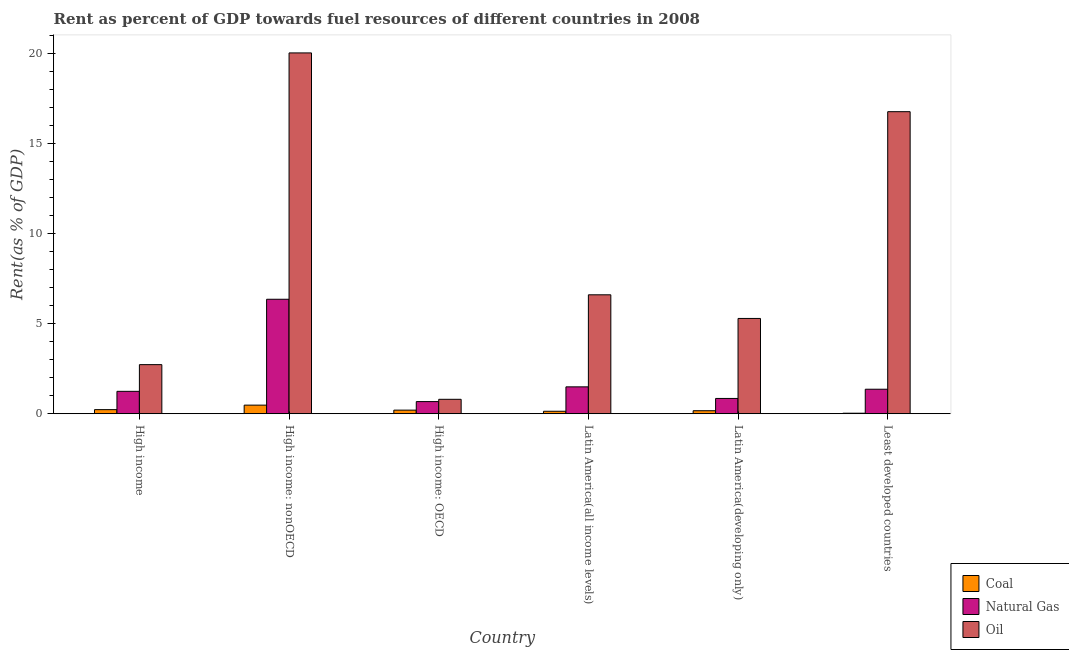How many different coloured bars are there?
Provide a short and direct response. 3. Are the number of bars per tick equal to the number of legend labels?
Your response must be concise. Yes. Are the number of bars on each tick of the X-axis equal?
Provide a succinct answer. Yes. How many bars are there on the 3rd tick from the left?
Make the answer very short. 3. What is the label of the 3rd group of bars from the left?
Your answer should be very brief. High income: OECD. What is the rent towards oil in Latin America(developing only)?
Keep it short and to the point. 5.29. Across all countries, what is the maximum rent towards natural gas?
Offer a terse response. 6.35. Across all countries, what is the minimum rent towards coal?
Make the answer very short. 0.03. In which country was the rent towards coal maximum?
Offer a terse response. High income: nonOECD. In which country was the rent towards natural gas minimum?
Your response must be concise. High income: OECD. What is the total rent towards coal in the graph?
Your answer should be compact. 1.24. What is the difference between the rent towards natural gas in High income: OECD and that in Latin America(developing only)?
Ensure brevity in your answer.  -0.17. What is the difference between the rent towards oil in Latin America(all income levels) and the rent towards natural gas in High income?
Provide a short and direct response. 5.36. What is the average rent towards natural gas per country?
Make the answer very short. 2. What is the difference between the rent towards coal and rent towards natural gas in High income?
Provide a succinct answer. -1.01. In how many countries, is the rent towards oil greater than 9 %?
Offer a very short reply. 2. What is the ratio of the rent towards natural gas in Latin America(developing only) to that in Least developed countries?
Your answer should be very brief. 0.62. What is the difference between the highest and the second highest rent towards oil?
Give a very brief answer. 3.26. What is the difference between the highest and the lowest rent towards coal?
Your answer should be compact. 0.45. What does the 1st bar from the left in Least developed countries represents?
Your answer should be compact. Coal. What does the 1st bar from the right in Least developed countries represents?
Your answer should be compact. Oil. How many bars are there?
Offer a terse response. 18. How many countries are there in the graph?
Make the answer very short. 6. What is the difference between two consecutive major ticks on the Y-axis?
Ensure brevity in your answer.  5. Are the values on the major ticks of Y-axis written in scientific E-notation?
Your response must be concise. No. Where does the legend appear in the graph?
Keep it short and to the point. Bottom right. How many legend labels are there?
Give a very brief answer. 3. How are the legend labels stacked?
Your answer should be compact. Vertical. What is the title of the graph?
Your response must be concise. Rent as percent of GDP towards fuel resources of different countries in 2008. Does "Food" appear as one of the legend labels in the graph?
Your answer should be very brief. No. What is the label or title of the Y-axis?
Provide a succinct answer. Rent(as % of GDP). What is the Rent(as % of GDP) of Coal in High income?
Provide a succinct answer. 0.23. What is the Rent(as % of GDP) of Natural Gas in High income?
Your answer should be compact. 1.24. What is the Rent(as % of GDP) of Oil in High income?
Keep it short and to the point. 2.73. What is the Rent(as % of GDP) of Coal in High income: nonOECD?
Give a very brief answer. 0.48. What is the Rent(as % of GDP) of Natural Gas in High income: nonOECD?
Give a very brief answer. 6.35. What is the Rent(as % of GDP) of Oil in High income: nonOECD?
Offer a terse response. 20.02. What is the Rent(as % of GDP) in Coal in High income: OECD?
Offer a very short reply. 0.2. What is the Rent(as % of GDP) in Natural Gas in High income: OECD?
Make the answer very short. 0.67. What is the Rent(as % of GDP) of Oil in High income: OECD?
Your answer should be compact. 0.8. What is the Rent(as % of GDP) of Coal in Latin America(all income levels)?
Keep it short and to the point. 0.14. What is the Rent(as % of GDP) of Natural Gas in Latin America(all income levels)?
Your response must be concise. 1.49. What is the Rent(as % of GDP) of Oil in Latin America(all income levels)?
Your response must be concise. 6.6. What is the Rent(as % of GDP) in Coal in Latin America(developing only)?
Ensure brevity in your answer.  0.17. What is the Rent(as % of GDP) of Natural Gas in Latin America(developing only)?
Offer a very short reply. 0.85. What is the Rent(as % of GDP) in Oil in Latin America(developing only)?
Your response must be concise. 5.29. What is the Rent(as % of GDP) of Coal in Least developed countries?
Provide a succinct answer. 0.03. What is the Rent(as % of GDP) of Natural Gas in Least developed countries?
Keep it short and to the point. 1.36. What is the Rent(as % of GDP) of Oil in Least developed countries?
Your response must be concise. 16.76. Across all countries, what is the maximum Rent(as % of GDP) of Coal?
Offer a terse response. 0.48. Across all countries, what is the maximum Rent(as % of GDP) in Natural Gas?
Make the answer very short. 6.35. Across all countries, what is the maximum Rent(as % of GDP) of Oil?
Offer a terse response. 20.02. Across all countries, what is the minimum Rent(as % of GDP) of Coal?
Make the answer very short. 0.03. Across all countries, what is the minimum Rent(as % of GDP) of Natural Gas?
Your response must be concise. 0.67. Across all countries, what is the minimum Rent(as % of GDP) in Oil?
Offer a terse response. 0.8. What is the total Rent(as % of GDP) in Coal in the graph?
Your response must be concise. 1.24. What is the total Rent(as % of GDP) of Natural Gas in the graph?
Make the answer very short. 11.97. What is the total Rent(as % of GDP) in Oil in the graph?
Ensure brevity in your answer.  52.19. What is the difference between the Rent(as % of GDP) in Coal in High income and that in High income: nonOECD?
Make the answer very short. -0.25. What is the difference between the Rent(as % of GDP) of Natural Gas in High income and that in High income: nonOECD?
Your response must be concise. -5.11. What is the difference between the Rent(as % of GDP) of Oil in High income and that in High income: nonOECD?
Offer a very short reply. -17.3. What is the difference between the Rent(as % of GDP) of Coal in High income and that in High income: OECD?
Provide a short and direct response. 0.03. What is the difference between the Rent(as % of GDP) of Natural Gas in High income and that in High income: OECD?
Provide a succinct answer. 0.57. What is the difference between the Rent(as % of GDP) of Oil in High income and that in High income: OECD?
Provide a succinct answer. 1.92. What is the difference between the Rent(as % of GDP) in Coal in High income and that in Latin America(all income levels)?
Offer a terse response. 0.09. What is the difference between the Rent(as % of GDP) of Natural Gas in High income and that in Latin America(all income levels)?
Your response must be concise. -0.25. What is the difference between the Rent(as % of GDP) in Oil in High income and that in Latin America(all income levels)?
Make the answer very short. -3.87. What is the difference between the Rent(as % of GDP) of Coal in High income and that in Latin America(developing only)?
Give a very brief answer. 0.06. What is the difference between the Rent(as % of GDP) in Natural Gas in High income and that in Latin America(developing only)?
Your answer should be compact. 0.39. What is the difference between the Rent(as % of GDP) in Oil in High income and that in Latin America(developing only)?
Your response must be concise. -2.56. What is the difference between the Rent(as % of GDP) of Coal in High income and that in Least developed countries?
Provide a succinct answer. 0.2. What is the difference between the Rent(as % of GDP) in Natural Gas in High income and that in Least developed countries?
Offer a terse response. -0.12. What is the difference between the Rent(as % of GDP) of Oil in High income and that in Least developed countries?
Your response must be concise. -14.03. What is the difference between the Rent(as % of GDP) in Coal in High income: nonOECD and that in High income: OECD?
Offer a terse response. 0.28. What is the difference between the Rent(as % of GDP) in Natural Gas in High income: nonOECD and that in High income: OECD?
Give a very brief answer. 5.68. What is the difference between the Rent(as % of GDP) of Oil in High income: nonOECD and that in High income: OECD?
Your response must be concise. 19.22. What is the difference between the Rent(as % of GDP) of Coal in High income: nonOECD and that in Latin America(all income levels)?
Provide a succinct answer. 0.34. What is the difference between the Rent(as % of GDP) of Natural Gas in High income: nonOECD and that in Latin America(all income levels)?
Ensure brevity in your answer.  4.86. What is the difference between the Rent(as % of GDP) of Oil in High income: nonOECD and that in Latin America(all income levels)?
Make the answer very short. 13.42. What is the difference between the Rent(as % of GDP) of Coal in High income: nonOECD and that in Latin America(developing only)?
Your answer should be compact. 0.31. What is the difference between the Rent(as % of GDP) of Natural Gas in High income: nonOECD and that in Latin America(developing only)?
Give a very brief answer. 5.5. What is the difference between the Rent(as % of GDP) in Oil in High income: nonOECD and that in Latin America(developing only)?
Make the answer very short. 14.73. What is the difference between the Rent(as % of GDP) of Coal in High income: nonOECD and that in Least developed countries?
Provide a succinct answer. 0.45. What is the difference between the Rent(as % of GDP) in Natural Gas in High income: nonOECD and that in Least developed countries?
Offer a very short reply. 4.99. What is the difference between the Rent(as % of GDP) in Oil in High income: nonOECD and that in Least developed countries?
Make the answer very short. 3.26. What is the difference between the Rent(as % of GDP) of Coal in High income: OECD and that in Latin America(all income levels)?
Your answer should be very brief. 0.06. What is the difference between the Rent(as % of GDP) in Natural Gas in High income: OECD and that in Latin America(all income levels)?
Offer a very short reply. -0.82. What is the difference between the Rent(as % of GDP) in Oil in High income: OECD and that in Latin America(all income levels)?
Give a very brief answer. -5.8. What is the difference between the Rent(as % of GDP) of Coal in High income: OECD and that in Latin America(developing only)?
Keep it short and to the point. 0.03. What is the difference between the Rent(as % of GDP) of Natural Gas in High income: OECD and that in Latin America(developing only)?
Your answer should be compact. -0.17. What is the difference between the Rent(as % of GDP) in Oil in High income: OECD and that in Latin America(developing only)?
Your answer should be compact. -4.49. What is the difference between the Rent(as % of GDP) in Coal in High income: OECD and that in Least developed countries?
Provide a short and direct response. 0.17. What is the difference between the Rent(as % of GDP) in Natural Gas in High income: OECD and that in Least developed countries?
Provide a short and direct response. -0.69. What is the difference between the Rent(as % of GDP) in Oil in High income: OECD and that in Least developed countries?
Keep it short and to the point. -15.96. What is the difference between the Rent(as % of GDP) of Coal in Latin America(all income levels) and that in Latin America(developing only)?
Keep it short and to the point. -0.03. What is the difference between the Rent(as % of GDP) in Natural Gas in Latin America(all income levels) and that in Latin America(developing only)?
Keep it short and to the point. 0.64. What is the difference between the Rent(as % of GDP) of Oil in Latin America(all income levels) and that in Latin America(developing only)?
Provide a short and direct response. 1.31. What is the difference between the Rent(as % of GDP) of Coal in Latin America(all income levels) and that in Least developed countries?
Make the answer very short. 0.11. What is the difference between the Rent(as % of GDP) in Natural Gas in Latin America(all income levels) and that in Least developed countries?
Your answer should be compact. 0.13. What is the difference between the Rent(as % of GDP) in Oil in Latin America(all income levels) and that in Least developed countries?
Provide a succinct answer. -10.16. What is the difference between the Rent(as % of GDP) in Coal in Latin America(developing only) and that in Least developed countries?
Offer a very short reply. 0.14. What is the difference between the Rent(as % of GDP) in Natural Gas in Latin America(developing only) and that in Least developed countries?
Your answer should be very brief. -0.51. What is the difference between the Rent(as % of GDP) of Oil in Latin America(developing only) and that in Least developed countries?
Your response must be concise. -11.47. What is the difference between the Rent(as % of GDP) in Coal in High income and the Rent(as % of GDP) in Natural Gas in High income: nonOECD?
Offer a very short reply. -6.12. What is the difference between the Rent(as % of GDP) in Coal in High income and the Rent(as % of GDP) in Oil in High income: nonOECD?
Give a very brief answer. -19.79. What is the difference between the Rent(as % of GDP) of Natural Gas in High income and the Rent(as % of GDP) of Oil in High income: nonOECD?
Provide a short and direct response. -18.78. What is the difference between the Rent(as % of GDP) in Coal in High income and the Rent(as % of GDP) in Natural Gas in High income: OECD?
Your answer should be very brief. -0.45. What is the difference between the Rent(as % of GDP) of Coal in High income and the Rent(as % of GDP) of Oil in High income: OECD?
Provide a succinct answer. -0.57. What is the difference between the Rent(as % of GDP) of Natural Gas in High income and the Rent(as % of GDP) of Oil in High income: OECD?
Offer a terse response. 0.44. What is the difference between the Rent(as % of GDP) in Coal in High income and the Rent(as % of GDP) in Natural Gas in Latin America(all income levels)?
Provide a succinct answer. -1.26. What is the difference between the Rent(as % of GDP) of Coal in High income and the Rent(as % of GDP) of Oil in Latin America(all income levels)?
Provide a short and direct response. -6.37. What is the difference between the Rent(as % of GDP) of Natural Gas in High income and the Rent(as % of GDP) of Oil in Latin America(all income levels)?
Provide a succinct answer. -5.36. What is the difference between the Rent(as % of GDP) in Coal in High income and the Rent(as % of GDP) in Natural Gas in Latin America(developing only)?
Keep it short and to the point. -0.62. What is the difference between the Rent(as % of GDP) of Coal in High income and the Rent(as % of GDP) of Oil in Latin America(developing only)?
Keep it short and to the point. -5.06. What is the difference between the Rent(as % of GDP) in Natural Gas in High income and the Rent(as % of GDP) in Oil in Latin America(developing only)?
Keep it short and to the point. -4.04. What is the difference between the Rent(as % of GDP) in Coal in High income and the Rent(as % of GDP) in Natural Gas in Least developed countries?
Give a very brief answer. -1.13. What is the difference between the Rent(as % of GDP) in Coal in High income and the Rent(as % of GDP) in Oil in Least developed countries?
Provide a short and direct response. -16.53. What is the difference between the Rent(as % of GDP) of Natural Gas in High income and the Rent(as % of GDP) of Oil in Least developed countries?
Ensure brevity in your answer.  -15.52. What is the difference between the Rent(as % of GDP) in Coal in High income: nonOECD and the Rent(as % of GDP) in Natural Gas in High income: OECD?
Keep it short and to the point. -0.2. What is the difference between the Rent(as % of GDP) in Coal in High income: nonOECD and the Rent(as % of GDP) in Oil in High income: OECD?
Provide a short and direct response. -0.32. What is the difference between the Rent(as % of GDP) of Natural Gas in High income: nonOECD and the Rent(as % of GDP) of Oil in High income: OECD?
Provide a succinct answer. 5.55. What is the difference between the Rent(as % of GDP) of Coal in High income: nonOECD and the Rent(as % of GDP) of Natural Gas in Latin America(all income levels)?
Provide a succinct answer. -1.01. What is the difference between the Rent(as % of GDP) in Coal in High income: nonOECD and the Rent(as % of GDP) in Oil in Latin America(all income levels)?
Offer a terse response. -6.12. What is the difference between the Rent(as % of GDP) in Natural Gas in High income: nonOECD and the Rent(as % of GDP) in Oil in Latin America(all income levels)?
Your answer should be very brief. -0.25. What is the difference between the Rent(as % of GDP) of Coal in High income: nonOECD and the Rent(as % of GDP) of Natural Gas in Latin America(developing only)?
Ensure brevity in your answer.  -0.37. What is the difference between the Rent(as % of GDP) of Coal in High income: nonOECD and the Rent(as % of GDP) of Oil in Latin America(developing only)?
Ensure brevity in your answer.  -4.81. What is the difference between the Rent(as % of GDP) of Natural Gas in High income: nonOECD and the Rent(as % of GDP) of Oil in Latin America(developing only)?
Offer a terse response. 1.06. What is the difference between the Rent(as % of GDP) of Coal in High income: nonOECD and the Rent(as % of GDP) of Natural Gas in Least developed countries?
Your response must be concise. -0.88. What is the difference between the Rent(as % of GDP) of Coal in High income: nonOECD and the Rent(as % of GDP) of Oil in Least developed countries?
Your answer should be compact. -16.28. What is the difference between the Rent(as % of GDP) in Natural Gas in High income: nonOECD and the Rent(as % of GDP) in Oil in Least developed countries?
Provide a succinct answer. -10.41. What is the difference between the Rent(as % of GDP) in Coal in High income: OECD and the Rent(as % of GDP) in Natural Gas in Latin America(all income levels)?
Your response must be concise. -1.29. What is the difference between the Rent(as % of GDP) of Coal in High income: OECD and the Rent(as % of GDP) of Oil in Latin America(all income levels)?
Your answer should be very brief. -6.4. What is the difference between the Rent(as % of GDP) in Natural Gas in High income: OECD and the Rent(as % of GDP) in Oil in Latin America(all income levels)?
Your response must be concise. -5.92. What is the difference between the Rent(as % of GDP) in Coal in High income: OECD and the Rent(as % of GDP) in Natural Gas in Latin America(developing only)?
Provide a short and direct response. -0.65. What is the difference between the Rent(as % of GDP) of Coal in High income: OECD and the Rent(as % of GDP) of Oil in Latin America(developing only)?
Provide a succinct answer. -5.09. What is the difference between the Rent(as % of GDP) of Natural Gas in High income: OECD and the Rent(as % of GDP) of Oil in Latin America(developing only)?
Keep it short and to the point. -4.61. What is the difference between the Rent(as % of GDP) in Coal in High income: OECD and the Rent(as % of GDP) in Natural Gas in Least developed countries?
Make the answer very short. -1.16. What is the difference between the Rent(as % of GDP) of Coal in High income: OECD and the Rent(as % of GDP) of Oil in Least developed countries?
Make the answer very short. -16.56. What is the difference between the Rent(as % of GDP) of Natural Gas in High income: OECD and the Rent(as % of GDP) of Oil in Least developed countries?
Your answer should be very brief. -16.08. What is the difference between the Rent(as % of GDP) in Coal in Latin America(all income levels) and the Rent(as % of GDP) in Natural Gas in Latin America(developing only)?
Your answer should be compact. -0.71. What is the difference between the Rent(as % of GDP) of Coal in Latin America(all income levels) and the Rent(as % of GDP) of Oil in Latin America(developing only)?
Make the answer very short. -5.15. What is the difference between the Rent(as % of GDP) of Natural Gas in Latin America(all income levels) and the Rent(as % of GDP) of Oil in Latin America(developing only)?
Offer a terse response. -3.8. What is the difference between the Rent(as % of GDP) of Coal in Latin America(all income levels) and the Rent(as % of GDP) of Natural Gas in Least developed countries?
Make the answer very short. -1.22. What is the difference between the Rent(as % of GDP) in Coal in Latin America(all income levels) and the Rent(as % of GDP) in Oil in Least developed countries?
Offer a terse response. -16.62. What is the difference between the Rent(as % of GDP) of Natural Gas in Latin America(all income levels) and the Rent(as % of GDP) of Oil in Least developed countries?
Keep it short and to the point. -15.27. What is the difference between the Rent(as % of GDP) of Coal in Latin America(developing only) and the Rent(as % of GDP) of Natural Gas in Least developed countries?
Offer a terse response. -1.19. What is the difference between the Rent(as % of GDP) of Coal in Latin America(developing only) and the Rent(as % of GDP) of Oil in Least developed countries?
Your answer should be very brief. -16.59. What is the difference between the Rent(as % of GDP) of Natural Gas in Latin America(developing only) and the Rent(as % of GDP) of Oil in Least developed countries?
Your response must be concise. -15.91. What is the average Rent(as % of GDP) in Coal per country?
Keep it short and to the point. 0.21. What is the average Rent(as % of GDP) in Natural Gas per country?
Make the answer very short. 2. What is the average Rent(as % of GDP) of Oil per country?
Ensure brevity in your answer.  8.7. What is the difference between the Rent(as % of GDP) of Coal and Rent(as % of GDP) of Natural Gas in High income?
Provide a succinct answer. -1.01. What is the difference between the Rent(as % of GDP) in Coal and Rent(as % of GDP) in Oil in High income?
Your answer should be very brief. -2.5. What is the difference between the Rent(as % of GDP) of Natural Gas and Rent(as % of GDP) of Oil in High income?
Offer a terse response. -1.48. What is the difference between the Rent(as % of GDP) of Coal and Rent(as % of GDP) of Natural Gas in High income: nonOECD?
Provide a short and direct response. -5.87. What is the difference between the Rent(as % of GDP) of Coal and Rent(as % of GDP) of Oil in High income: nonOECD?
Offer a very short reply. -19.54. What is the difference between the Rent(as % of GDP) of Natural Gas and Rent(as % of GDP) of Oil in High income: nonOECD?
Provide a short and direct response. -13.67. What is the difference between the Rent(as % of GDP) in Coal and Rent(as % of GDP) in Natural Gas in High income: OECD?
Your answer should be very brief. -0.47. What is the difference between the Rent(as % of GDP) in Coal and Rent(as % of GDP) in Oil in High income: OECD?
Give a very brief answer. -0.6. What is the difference between the Rent(as % of GDP) in Natural Gas and Rent(as % of GDP) in Oil in High income: OECD?
Your answer should be very brief. -0.13. What is the difference between the Rent(as % of GDP) of Coal and Rent(as % of GDP) of Natural Gas in Latin America(all income levels)?
Offer a very short reply. -1.35. What is the difference between the Rent(as % of GDP) in Coal and Rent(as % of GDP) in Oil in Latin America(all income levels)?
Your answer should be very brief. -6.46. What is the difference between the Rent(as % of GDP) of Natural Gas and Rent(as % of GDP) of Oil in Latin America(all income levels)?
Provide a succinct answer. -5.11. What is the difference between the Rent(as % of GDP) in Coal and Rent(as % of GDP) in Natural Gas in Latin America(developing only)?
Provide a short and direct response. -0.68. What is the difference between the Rent(as % of GDP) of Coal and Rent(as % of GDP) of Oil in Latin America(developing only)?
Offer a very short reply. -5.12. What is the difference between the Rent(as % of GDP) in Natural Gas and Rent(as % of GDP) in Oil in Latin America(developing only)?
Your answer should be very brief. -4.44. What is the difference between the Rent(as % of GDP) in Coal and Rent(as % of GDP) in Natural Gas in Least developed countries?
Your response must be concise. -1.33. What is the difference between the Rent(as % of GDP) of Coal and Rent(as % of GDP) of Oil in Least developed countries?
Make the answer very short. -16.73. What is the difference between the Rent(as % of GDP) in Natural Gas and Rent(as % of GDP) in Oil in Least developed countries?
Offer a terse response. -15.4. What is the ratio of the Rent(as % of GDP) of Coal in High income to that in High income: nonOECD?
Offer a very short reply. 0.48. What is the ratio of the Rent(as % of GDP) in Natural Gas in High income to that in High income: nonOECD?
Your response must be concise. 0.2. What is the ratio of the Rent(as % of GDP) of Oil in High income to that in High income: nonOECD?
Your answer should be very brief. 0.14. What is the ratio of the Rent(as % of GDP) in Coal in High income to that in High income: OECD?
Offer a very short reply. 1.14. What is the ratio of the Rent(as % of GDP) of Natural Gas in High income to that in High income: OECD?
Your answer should be very brief. 1.84. What is the ratio of the Rent(as % of GDP) of Oil in High income to that in High income: OECD?
Offer a terse response. 3.4. What is the ratio of the Rent(as % of GDP) in Coal in High income to that in Latin America(all income levels)?
Your answer should be very brief. 1.66. What is the ratio of the Rent(as % of GDP) of Oil in High income to that in Latin America(all income levels)?
Ensure brevity in your answer.  0.41. What is the ratio of the Rent(as % of GDP) in Coal in High income to that in Latin America(developing only)?
Offer a terse response. 1.37. What is the ratio of the Rent(as % of GDP) in Natural Gas in High income to that in Latin America(developing only)?
Your response must be concise. 1.47. What is the ratio of the Rent(as % of GDP) in Oil in High income to that in Latin America(developing only)?
Offer a very short reply. 0.52. What is the ratio of the Rent(as % of GDP) in Coal in High income to that in Least developed countries?
Give a very brief answer. 7.73. What is the ratio of the Rent(as % of GDP) of Natural Gas in High income to that in Least developed countries?
Your answer should be compact. 0.91. What is the ratio of the Rent(as % of GDP) of Oil in High income to that in Least developed countries?
Keep it short and to the point. 0.16. What is the ratio of the Rent(as % of GDP) of Coal in High income: nonOECD to that in High income: OECD?
Give a very brief answer. 2.38. What is the ratio of the Rent(as % of GDP) of Natural Gas in High income: nonOECD to that in High income: OECD?
Offer a very short reply. 9.41. What is the ratio of the Rent(as % of GDP) of Oil in High income: nonOECD to that in High income: OECD?
Offer a very short reply. 24.99. What is the ratio of the Rent(as % of GDP) of Coal in High income: nonOECD to that in Latin America(all income levels)?
Offer a very short reply. 3.47. What is the ratio of the Rent(as % of GDP) in Natural Gas in High income: nonOECD to that in Latin America(all income levels)?
Ensure brevity in your answer.  4.26. What is the ratio of the Rent(as % of GDP) of Oil in High income: nonOECD to that in Latin America(all income levels)?
Your answer should be compact. 3.03. What is the ratio of the Rent(as % of GDP) in Coal in High income: nonOECD to that in Latin America(developing only)?
Offer a terse response. 2.86. What is the ratio of the Rent(as % of GDP) in Natural Gas in High income: nonOECD to that in Latin America(developing only)?
Your answer should be compact. 7.49. What is the ratio of the Rent(as % of GDP) of Oil in High income: nonOECD to that in Latin America(developing only)?
Offer a very short reply. 3.79. What is the ratio of the Rent(as % of GDP) of Coal in High income: nonOECD to that in Least developed countries?
Keep it short and to the point. 16.17. What is the ratio of the Rent(as % of GDP) of Natural Gas in High income: nonOECD to that in Least developed countries?
Provide a succinct answer. 4.67. What is the ratio of the Rent(as % of GDP) in Oil in High income: nonOECD to that in Least developed countries?
Offer a very short reply. 1.19. What is the ratio of the Rent(as % of GDP) of Coal in High income: OECD to that in Latin America(all income levels)?
Your response must be concise. 1.46. What is the ratio of the Rent(as % of GDP) in Natural Gas in High income: OECD to that in Latin America(all income levels)?
Provide a succinct answer. 0.45. What is the ratio of the Rent(as % of GDP) in Oil in High income: OECD to that in Latin America(all income levels)?
Provide a short and direct response. 0.12. What is the ratio of the Rent(as % of GDP) of Coal in High income: OECD to that in Latin America(developing only)?
Your answer should be very brief. 1.2. What is the ratio of the Rent(as % of GDP) in Natural Gas in High income: OECD to that in Latin America(developing only)?
Your response must be concise. 0.8. What is the ratio of the Rent(as % of GDP) of Oil in High income: OECD to that in Latin America(developing only)?
Your answer should be compact. 0.15. What is the ratio of the Rent(as % of GDP) of Coal in High income: OECD to that in Least developed countries?
Your response must be concise. 6.79. What is the ratio of the Rent(as % of GDP) in Natural Gas in High income: OECD to that in Least developed countries?
Your answer should be compact. 0.5. What is the ratio of the Rent(as % of GDP) in Oil in High income: OECD to that in Least developed countries?
Keep it short and to the point. 0.05. What is the ratio of the Rent(as % of GDP) of Coal in Latin America(all income levels) to that in Latin America(developing only)?
Your response must be concise. 0.83. What is the ratio of the Rent(as % of GDP) of Natural Gas in Latin America(all income levels) to that in Latin America(developing only)?
Keep it short and to the point. 1.76. What is the ratio of the Rent(as % of GDP) of Oil in Latin America(all income levels) to that in Latin America(developing only)?
Your answer should be very brief. 1.25. What is the ratio of the Rent(as % of GDP) of Coal in Latin America(all income levels) to that in Least developed countries?
Provide a succinct answer. 4.66. What is the ratio of the Rent(as % of GDP) in Natural Gas in Latin America(all income levels) to that in Least developed countries?
Offer a terse response. 1.1. What is the ratio of the Rent(as % of GDP) of Oil in Latin America(all income levels) to that in Least developed countries?
Your answer should be very brief. 0.39. What is the ratio of the Rent(as % of GDP) in Coal in Latin America(developing only) to that in Least developed countries?
Your answer should be very brief. 5.65. What is the ratio of the Rent(as % of GDP) in Natural Gas in Latin America(developing only) to that in Least developed countries?
Offer a terse response. 0.62. What is the ratio of the Rent(as % of GDP) of Oil in Latin America(developing only) to that in Least developed countries?
Ensure brevity in your answer.  0.32. What is the difference between the highest and the second highest Rent(as % of GDP) in Coal?
Ensure brevity in your answer.  0.25. What is the difference between the highest and the second highest Rent(as % of GDP) in Natural Gas?
Ensure brevity in your answer.  4.86. What is the difference between the highest and the second highest Rent(as % of GDP) of Oil?
Keep it short and to the point. 3.26. What is the difference between the highest and the lowest Rent(as % of GDP) of Coal?
Provide a succinct answer. 0.45. What is the difference between the highest and the lowest Rent(as % of GDP) in Natural Gas?
Ensure brevity in your answer.  5.68. What is the difference between the highest and the lowest Rent(as % of GDP) in Oil?
Provide a short and direct response. 19.22. 